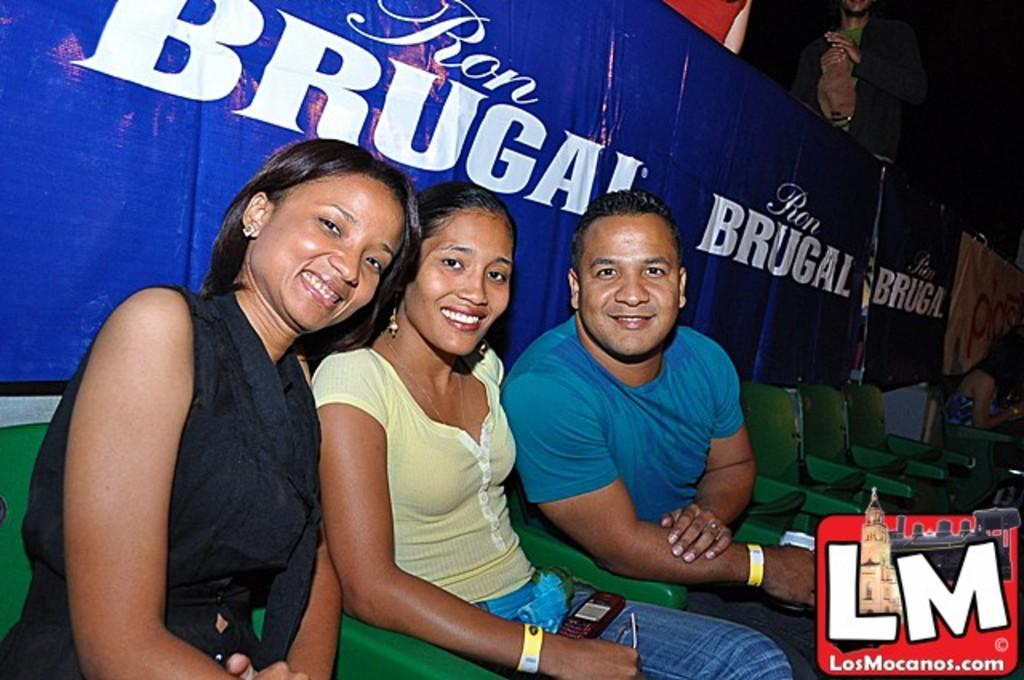How many people are in the image? There are two women and a man in the image, making a total of three people. What are the people in the image doing? The people are sitting on chairs and smiling. Can you describe the background of the image? There are chairs and people visible in the background of the image. Is there any additional information about the image? Yes, there is a watermark in the image. What type of muscle is visible on the man's stomach in the image? There is no muscle or stomach visible on the man in the image; the focus is on the people sitting on chairs and smiling. 